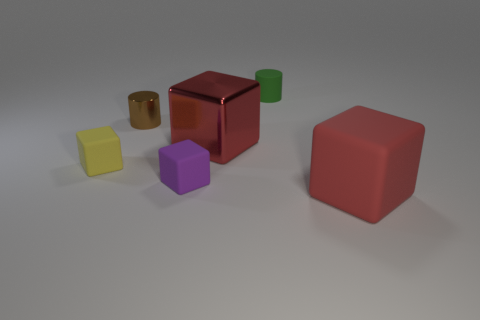Is there a tiny yellow matte object of the same shape as the red rubber thing?
Give a very brief answer. Yes. What is the shape of the small purple matte thing?
Offer a terse response. Cube. What is the material of the large red object that is on the right side of the big red cube behind the object in front of the purple matte block?
Your response must be concise. Rubber. Are there more tiny brown metallic cylinders in front of the red metallic cube than brown cylinders?
Make the answer very short. No. There is another red thing that is the same size as the red rubber object; what is its material?
Keep it short and to the point. Metal. Is there a gray metallic cylinder that has the same size as the purple matte object?
Provide a succinct answer. No. What is the size of the red object that is to the right of the large red metal block?
Make the answer very short. Large. What is the size of the brown shiny cylinder?
Keep it short and to the point. Small. How many blocks are brown shiny things or purple matte things?
Offer a very short reply. 1. What is the size of the red block that is made of the same material as the small brown cylinder?
Keep it short and to the point. Large. 